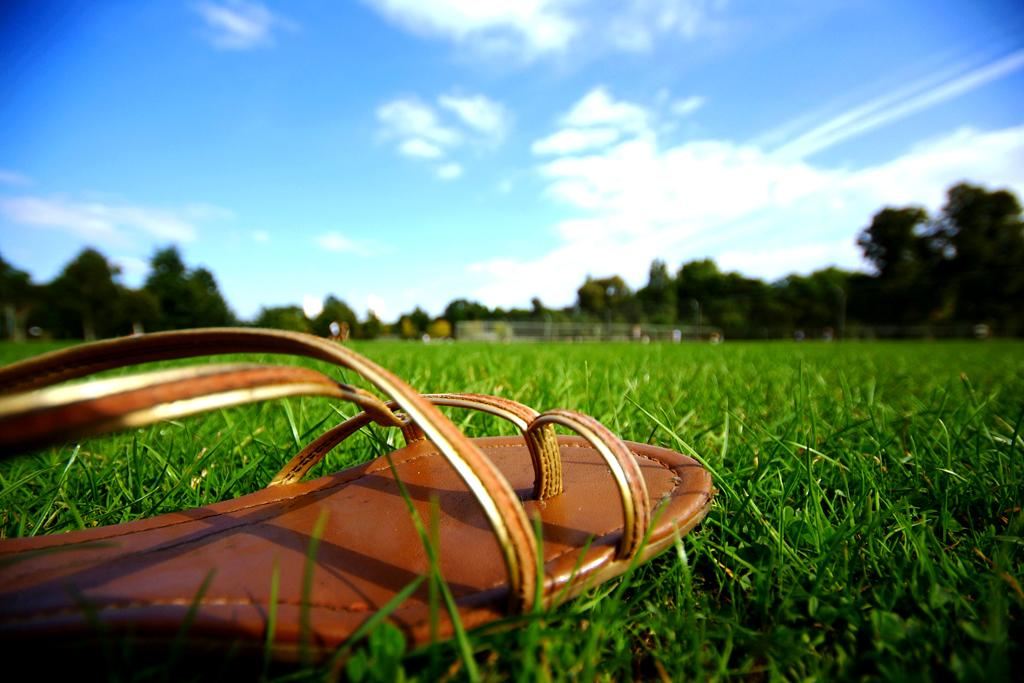What is located in the foreground of the image? There is footwear in the foreground of the image. Where is the footwear placed? The footwear is on the grass. What can be seen in the background of the image? There are trees and the sky visible in the background of the image. What is the condition of the sky in the image? The sky has clouds in it. What type of disease is being treated by the expert in the image? There is no expert or disease present in the image; it features footwear on the grass with trees and clouds in the background. 